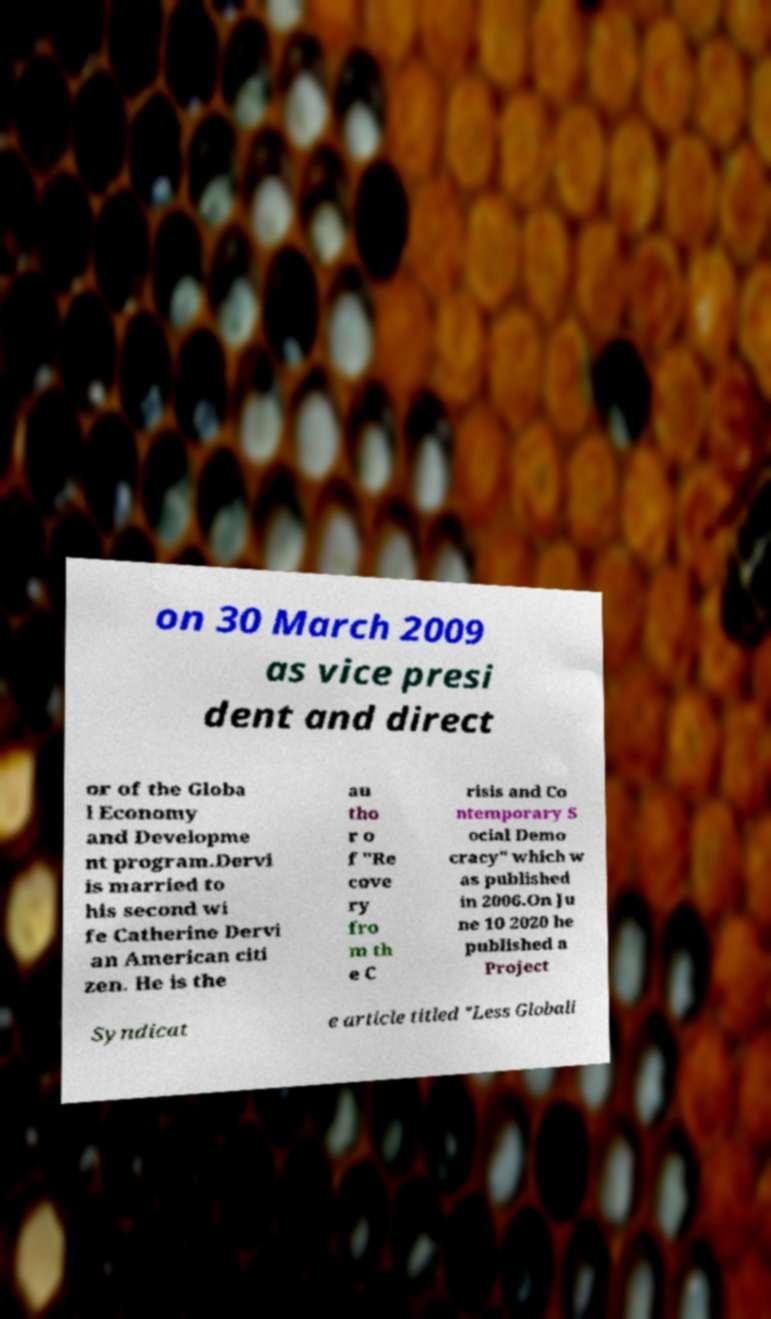For documentation purposes, I need the text within this image transcribed. Could you provide that? on 30 March 2009 as vice presi dent and direct or of the Globa l Economy and Developme nt program.Dervi is married to his second wi fe Catherine Dervi an American citi zen. He is the au tho r o f "Re cove ry fro m th e C risis and Co ntemporary S ocial Demo cracy" which w as published in 2006.On Ju ne 10 2020 he published a Project Syndicat e article titled "Less Globali 